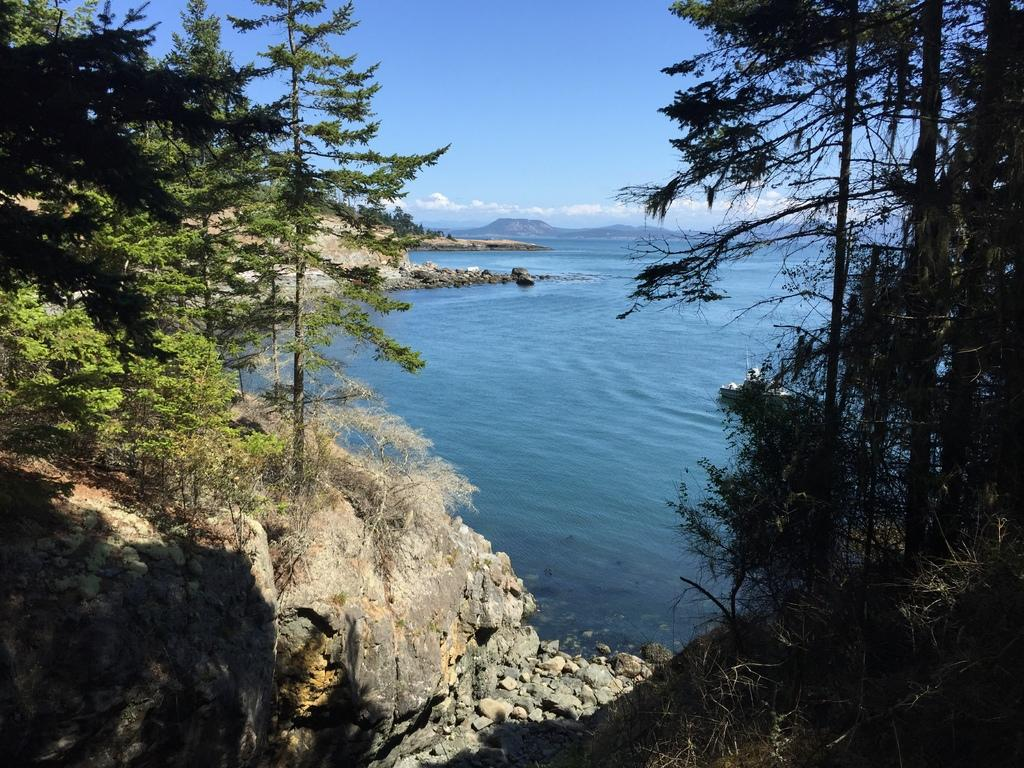What type of vegetation is present in the image? There are green trees in the image. What natural element can be seen besides the trees? There is water visible in the image. What color is the sky in the image? The sky is blue in the image. What type of glove is hanging from the tree in the image? There is no glove present in the image; it only features green trees, water, and a blue sky. How many plates are stacked on the tree in the image? There are no plates present in the image; it only features green trees, water, and a blue sky. 